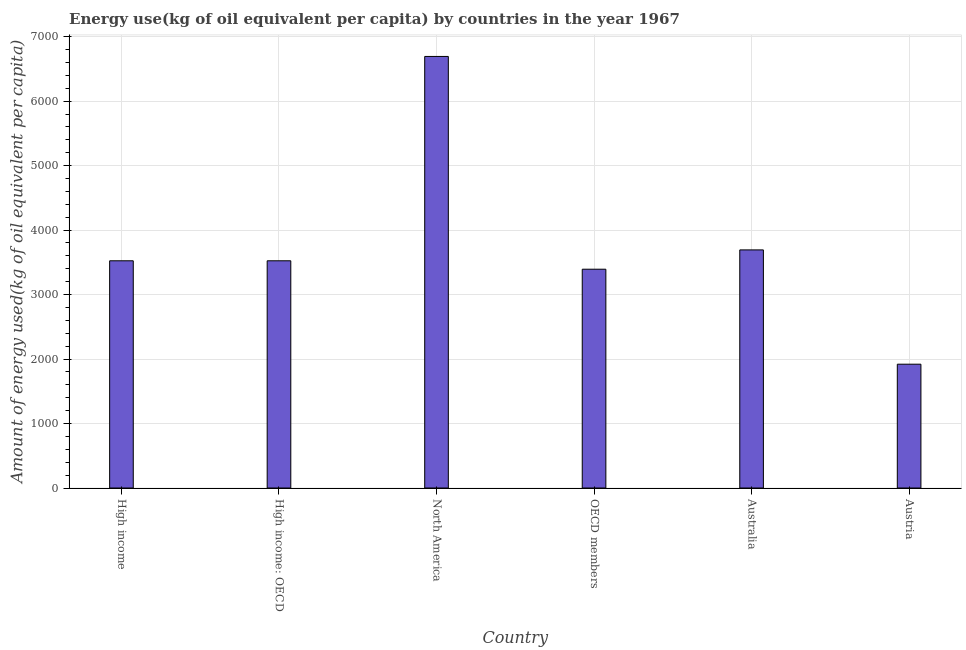Does the graph contain any zero values?
Your response must be concise. No. Does the graph contain grids?
Give a very brief answer. Yes. What is the title of the graph?
Ensure brevity in your answer.  Energy use(kg of oil equivalent per capita) by countries in the year 1967. What is the label or title of the Y-axis?
Provide a succinct answer. Amount of energy used(kg of oil equivalent per capita). What is the amount of energy used in Australia?
Provide a succinct answer. 3692.81. Across all countries, what is the maximum amount of energy used?
Your response must be concise. 6693.14. Across all countries, what is the minimum amount of energy used?
Make the answer very short. 1920.21. In which country was the amount of energy used minimum?
Provide a short and direct response. Austria. What is the sum of the amount of energy used?
Keep it short and to the point. 2.27e+04. What is the difference between the amount of energy used in Austria and North America?
Offer a very short reply. -4772.93. What is the average amount of energy used per country?
Keep it short and to the point. 3791.32. What is the median amount of energy used?
Provide a short and direct response. 3524.12. In how many countries, is the amount of energy used greater than 3200 kg?
Your answer should be very brief. 5. What is the ratio of the amount of energy used in Australia to that in OECD members?
Make the answer very short. 1.09. Is the amount of energy used in Austria less than that in High income: OECD?
Provide a succinct answer. Yes. What is the difference between the highest and the second highest amount of energy used?
Your answer should be very brief. 3000.34. What is the difference between the highest and the lowest amount of energy used?
Give a very brief answer. 4772.93. How many bars are there?
Ensure brevity in your answer.  6. How many countries are there in the graph?
Offer a terse response. 6. What is the difference between two consecutive major ticks on the Y-axis?
Keep it short and to the point. 1000. Are the values on the major ticks of Y-axis written in scientific E-notation?
Your answer should be compact. No. What is the Amount of energy used(kg of oil equivalent per capita) in High income?
Your response must be concise. 3524.12. What is the Amount of energy used(kg of oil equivalent per capita) of High income: OECD?
Your response must be concise. 3524.12. What is the Amount of energy used(kg of oil equivalent per capita) in North America?
Make the answer very short. 6693.14. What is the Amount of energy used(kg of oil equivalent per capita) of OECD members?
Your response must be concise. 3393.49. What is the Amount of energy used(kg of oil equivalent per capita) of Australia?
Make the answer very short. 3692.81. What is the Amount of energy used(kg of oil equivalent per capita) in Austria?
Offer a terse response. 1920.21. What is the difference between the Amount of energy used(kg of oil equivalent per capita) in High income and North America?
Ensure brevity in your answer.  -3169.02. What is the difference between the Amount of energy used(kg of oil equivalent per capita) in High income and OECD members?
Keep it short and to the point. 130.63. What is the difference between the Amount of energy used(kg of oil equivalent per capita) in High income and Australia?
Provide a short and direct response. -168.69. What is the difference between the Amount of energy used(kg of oil equivalent per capita) in High income and Austria?
Make the answer very short. 1603.91. What is the difference between the Amount of energy used(kg of oil equivalent per capita) in High income: OECD and North America?
Provide a short and direct response. -3169.02. What is the difference between the Amount of energy used(kg of oil equivalent per capita) in High income: OECD and OECD members?
Keep it short and to the point. 130.63. What is the difference between the Amount of energy used(kg of oil equivalent per capita) in High income: OECD and Australia?
Keep it short and to the point. -168.69. What is the difference between the Amount of energy used(kg of oil equivalent per capita) in High income: OECD and Austria?
Offer a terse response. 1603.91. What is the difference between the Amount of energy used(kg of oil equivalent per capita) in North America and OECD members?
Give a very brief answer. 3299.66. What is the difference between the Amount of energy used(kg of oil equivalent per capita) in North America and Australia?
Your response must be concise. 3000.34. What is the difference between the Amount of energy used(kg of oil equivalent per capita) in North America and Austria?
Your answer should be compact. 4772.93. What is the difference between the Amount of energy used(kg of oil equivalent per capita) in OECD members and Australia?
Offer a terse response. -299.32. What is the difference between the Amount of energy used(kg of oil equivalent per capita) in OECD members and Austria?
Give a very brief answer. 1473.28. What is the difference between the Amount of energy used(kg of oil equivalent per capita) in Australia and Austria?
Make the answer very short. 1772.6. What is the ratio of the Amount of energy used(kg of oil equivalent per capita) in High income to that in High income: OECD?
Provide a succinct answer. 1. What is the ratio of the Amount of energy used(kg of oil equivalent per capita) in High income to that in North America?
Your answer should be very brief. 0.53. What is the ratio of the Amount of energy used(kg of oil equivalent per capita) in High income to that in OECD members?
Your response must be concise. 1.04. What is the ratio of the Amount of energy used(kg of oil equivalent per capita) in High income to that in Australia?
Make the answer very short. 0.95. What is the ratio of the Amount of energy used(kg of oil equivalent per capita) in High income to that in Austria?
Your response must be concise. 1.83. What is the ratio of the Amount of energy used(kg of oil equivalent per capita) in High income: OECD to that in North America?
Your answer should be very brief. 0.53. What is the ratio of the Amount of energy used(kg of oil equivalent per capita) in High income: OECD to that in OECD members?
Give a very brief answer. 1.04. What is the ratio of the Amount of energy used(kg of oil equivalent per capita) in High income: OECD to that in Australia?
Offer a terse response. 0.95. What is the ratio of the Amount of energy used(kg of oil equivalent per capita) in High income: OECD to that in Austria?
Your answer should be compact. 1.83. What is the ratio of the Amount of energy used(kg of oil equivalent per capita) in North America to that in OECD members?
Your response must be concise. 1.97. What is the ratio of the Amount of energy used(kg of oil equivalent per capita) in North America to that in Australia?
Your answer should be very brief. 1.81. What is the ratio of the Amount of energy used(kg of oil equivalent per capita) in North America to that in Austria?
Give a very brief answer. 3.49. What is the ratio of the Amount of energy used(kg of oil equivalent per capita) in OECD members to that in Australia?
Keep it short and to the point. 0.92. What is the ratio of the Amount of energy used(kg of oil equivalent per capita) in OECD members to that in Austria?
Offer a very short reply. 1.77. What is the ratio of the Amount of energy used(kg of oil equivalent per capita) in Australia to that in Austria?
Your response must be concise. 1.92. 